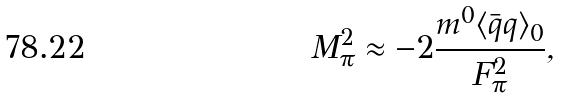<formula> <loc_0><loc_0><loc_500><loc_500>M _ { \pi } ^ { 2 } \approx - 2 \frac { m ^ { 0 } \langle \bar { q } q \rangle _ { 0 } } { F _ { \pi } ^ { 2 } } ,</formula> 